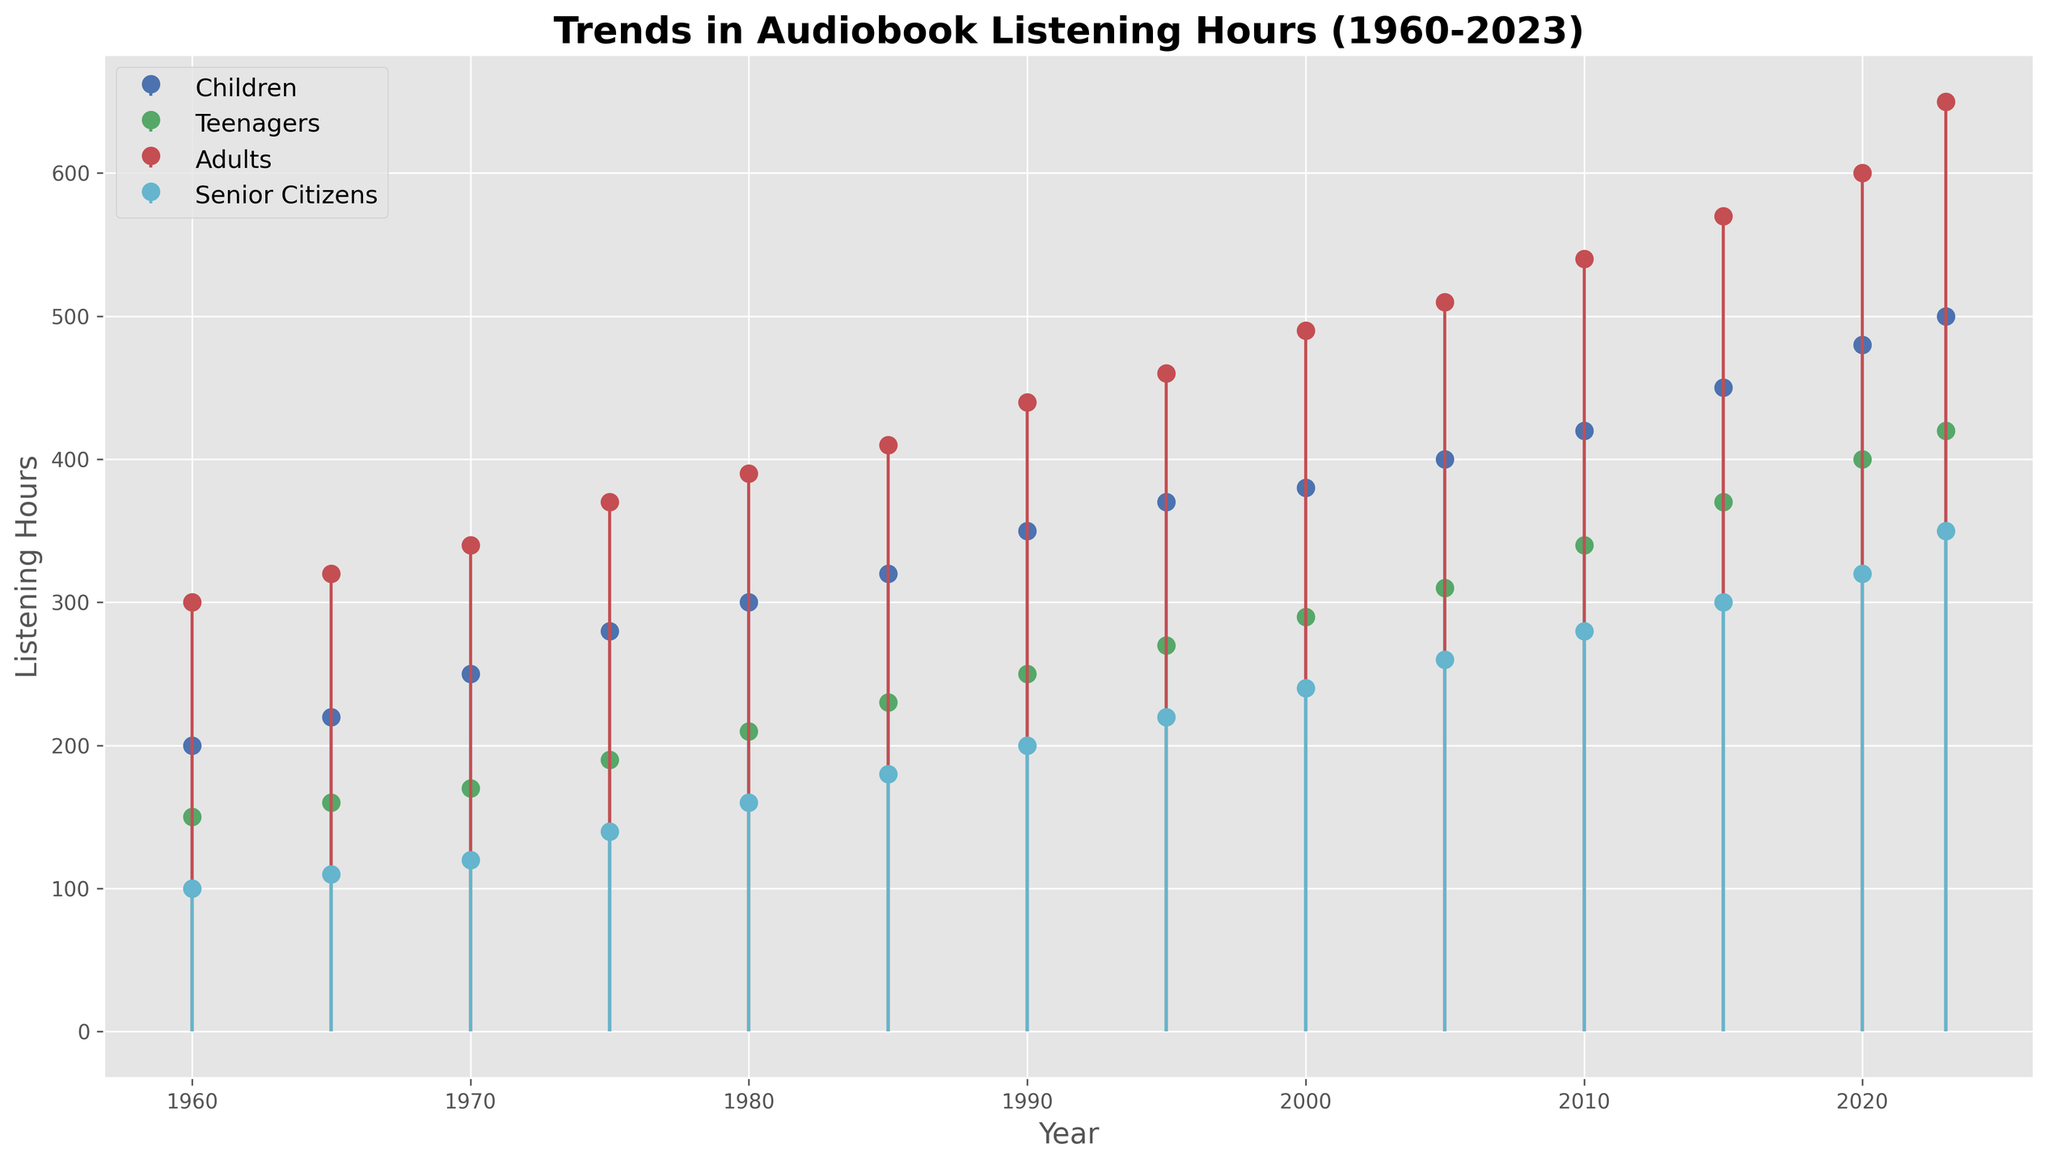Which age group showed the highest increase in audiobook listening hours from 1960 to 2023? To determine this, we need to compare the listening hours for each age group in 1960 and 2023, and then find the difference for each group. The increase for Children is 500 - 200 = 300, for Teenagers is 420 - 150 = 270, for Adults is 650 - 300 = 350, and for Senior Citizens is 350 - 100 = 250. The highest increase is seen in Adults.
Answer: Adults How did the listening hours for Senior Citizens change from 1960 to 1980? We need to find the listening hours for Senior Citizens in 1960 and 1980 and then calculate the difference. In 1960 it was 100 hours, and in 1980 it was 160 hours, so the change is 160 - 100 = 60.
Answer: Increased by 60 hours Which age group consistently had the highest listening hours throughout the given period? We need to observe the entire timeline and identify the age group that consistently had the highest values. Adults consistently had the highest listening hours from 1960 to 2023.
Answer: Adults Was there any year where the audiobook listening hours of Teenagers surpassed those of Children? To answer this, we look at the plot for any crossover between the lines representing Teenagers and Children. No such crossover occurs; therefore, Teenagers never surpassed Children in listening hours.
Answer: No In 2000, what was the total audiobook listening hours across all age groups? We sum up the listening hours for all age groups for the year 2000. Children: 380, Teenagers: 290, Adults: 490, Senior Citizens: 240. So, 380 + 290 + 490 + 240 = 1400.
Answer: 1400 hours Between 1990 and 2000, which age group saw the smallest increase in audiobook listening hours? We calculate the difference in listening hours for each age group from 1990 to 2000. Children: 380 - 350 = 30, Teenagers: 290 - 250 = 40, Adults: 490 - 440 = 50, Senior Citizens: 240 - 200 = 40. The smallest increase was for Children.
Answer: Children What is the ratio of audiobook listening hours of Adults to Children in 2023? We need to divide the listening hours of Adults by those of Children in 2023. Adults: 650, Children: 500. So, the ratio is 650 / 500 = 1.3.
Answer: 1.3 Looking at the trends, by how much have audiobook listening hours increased for Teenagers from 1985 to 2023? We find the difference in listening hours for Teenagers between 1985 and 2023. In 1985 it was 230, and in 2023 it was 420, so the increase is 420 - 230 = 190.
Answer: 190 hours Between 2015 and 2023, which age group had the greatest absolute increase in audiobook listening hours? We calculate the difference in listening hours for each age group between 2015 and 2023. Children: 500 - 450 = 50, Teenagers: 420 - 370 = 50, Adults: 650 - 570 = 80, Senior Citizens: 350 - 300 = 50. The greatest absolute increase is seen in Adults.
Answer: Adults What was the average number of listening hours for Senior Citizens from 1960 to 2023? We find the average by summing the listening hours for Senior Citizens from 1960 to 2023 and dividing by the number of data points. (100 + 110 + 120 + 140 + 160 + 180 + 200 + 220 + 240 + 260 + 280 + 300 + 320 + 350) / 14. This totals to 3000 / 14 ≈ 214.29.
Answer: 214.29 hours 